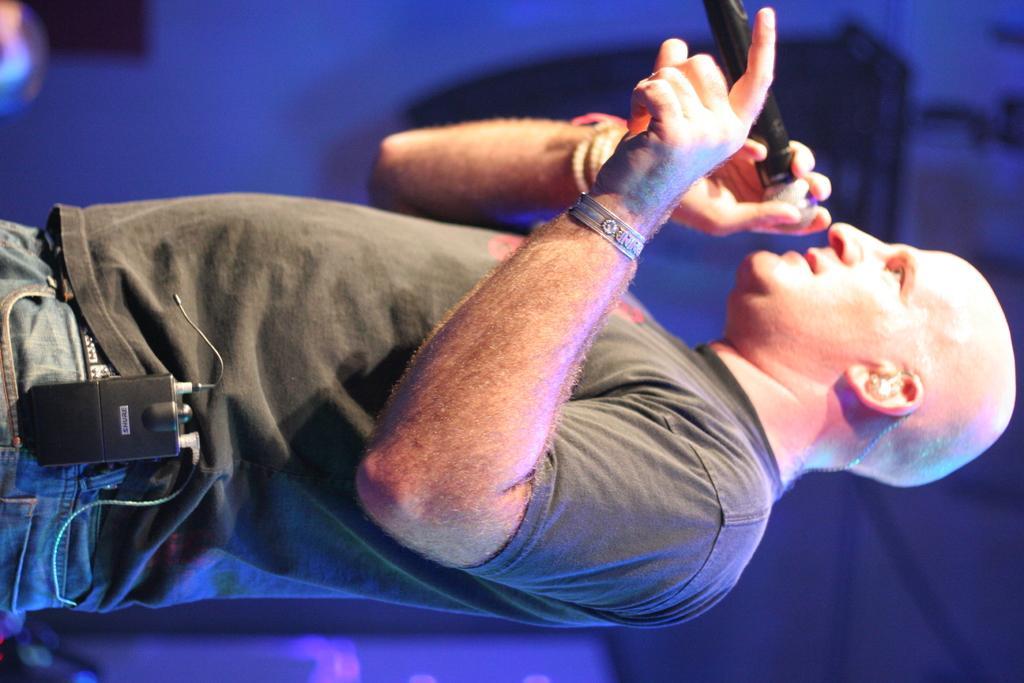Please provide a concise description of this image. In this image we can see a person holding a mic in his hands, wearing a T-Shirt and putting an object in his jeans. 